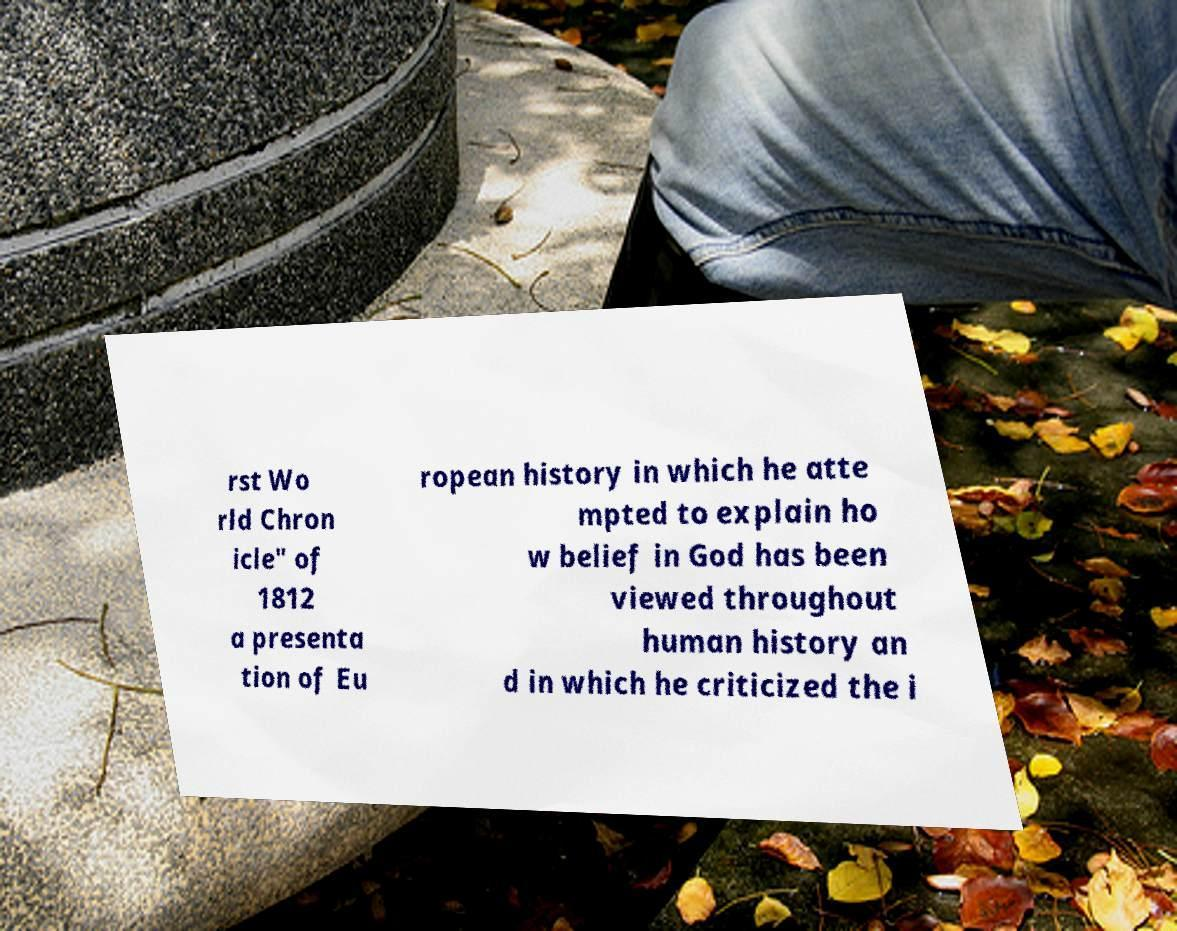Could you assist in decoding the text presented in this image and type it out clearly? rst Wo rld Chron icle" of 1812 a presenta tion of Eu ropean history in which he atte mpted to explain ho w belief in God has been viewed throughout human history an d in which he criticized the i 